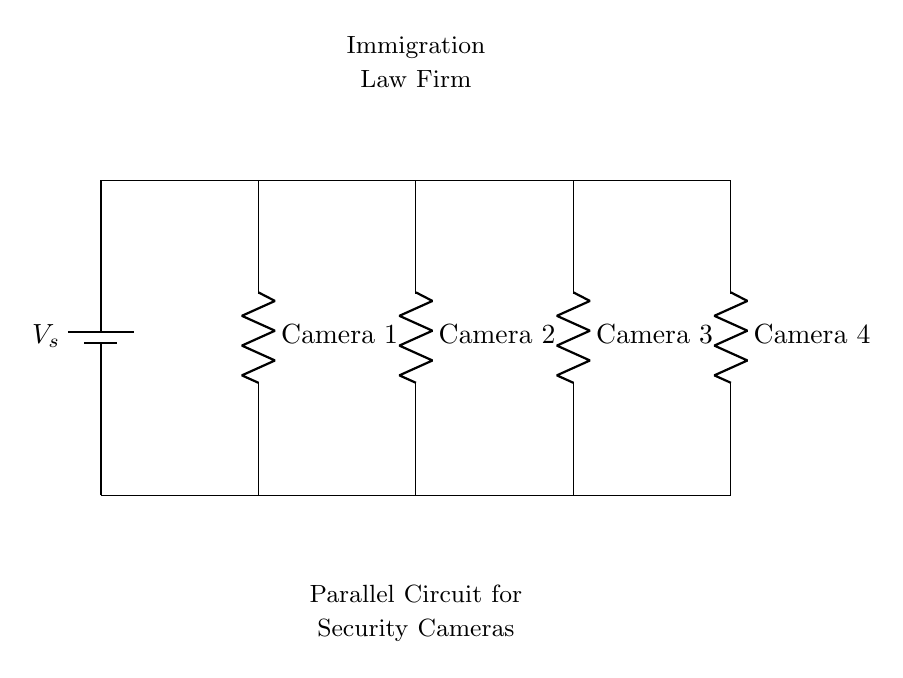What type of circuit is this? This is a parallel circuit, as indicated by the configuration where multiple components (security cameras) are connected across the same two nodes of the voltage source, allowing each camera to operate independently.
Answer: Parallel How many security cameras are connected in this circuit? There are four security cameras connected in the circuit, as shown by the four labeled components (Camera 1, Camera 2, Camera 3, Camera 4) along the top of the diagram.
Answer: Four What is the purpose of the voltage source? The voltage source provides electrical power to the connected security cameras, enabling them to operate and function correctly within the circuit's design.
Answer: Power What happens to the voltage across each camera? Each camera receives the same voltage as the source voltage because in a parallel circuit, voltage remains constant across all components connected in parallel.
Answer: Same voltage If one camera fails, what happens to the others? If one camera fails, the others continue to function because they are connected in parallel, allowing the electric current to bypass the failed camera.
Answer: Continue functioning What is the significance of using a parallel circuit for security cameras? The significance lies in the ability to maintain operation of each camera independently, increasing reliability and ensuring all areas are still monitored even if one unit fails.
Answer: Increased reliability 